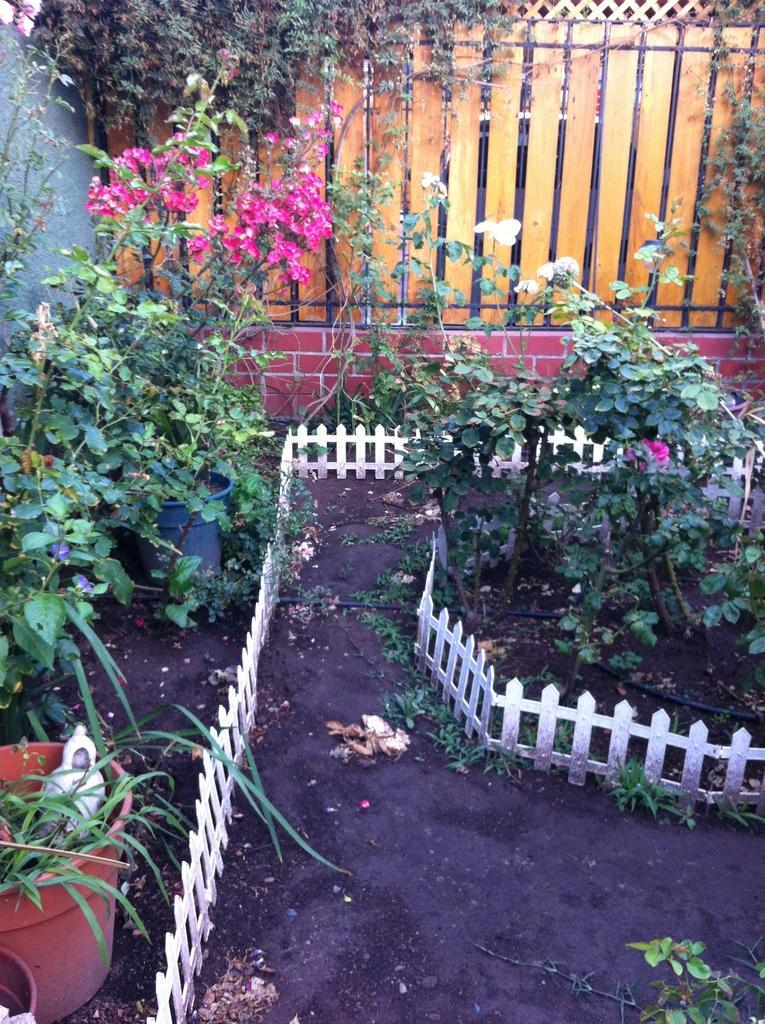What type of living organisms can be seen in the image? Plants can be seen in the image. What type of structure is present in the image? There is fencing and a wall in the image. What type of ear is visible on the plant in the image? There are no ears present in the image, as plants do not have ears. 